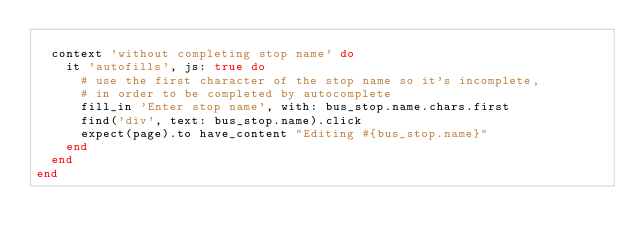Convert code to text. <code><loc_0><loc_0><loc_500><loc_500><_Ruby_>
  context 'without completing stop name' do
    it 'autofills', js: true do
      # use the first character of the stop name so it's incomplete,
      # in order to be completed by autocomplete
      fill_in 'Enter stop name', with: bus_stop.name.chars.first
      find('div', text: bus_stop.name).click
      expect(page).to have_content "Editing #{bus_stop.name}"
    end
  end
end
</code> 